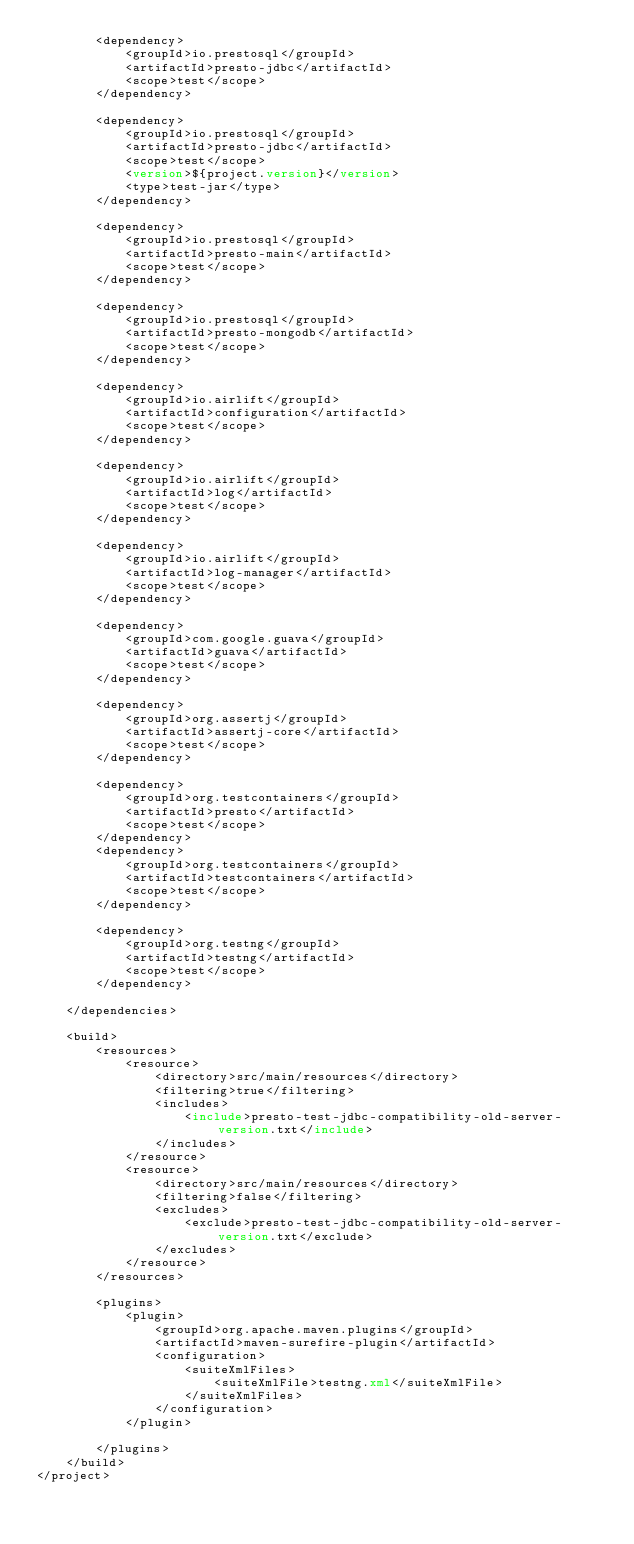<code> <loc_0><loc_0><loc_500><loc_500><_XML_>        <dependency>
            <groupId>io.prestosql</groupId>
            <artifactId>presto-jdbc</artifactId>
            <scope>test</scope>
        </dependency>

        <dependency>
            <groupId>io.prestosql</groupId>
            <artifactId>presto-jdbc</artifactId>
            <scope>test</scope>
            <version>${project.version}</version>
            <type>test-jar</type>
        </dependency>

        <dependency>
            <groupId>io.prestosql</groupId>
            <artifactId>presto-main</artifactId>
            <scope>test</scope>
        </dependency>

        <dependency>
            <groupId>io.prestosql</groupId>
            <artifactId>presto-mongodb</artifactId>
            <scope>test</scope>
        </dependency>

        <dependency>
            <groupId>io.airlift</groupId>
            <artifactId>configuration</artifactId>
            <scope>test</scope>
        </dependency>

        <dependency>
            <groupId>io.airlift</groupId>
            <artifactId>log</artifactId>
            <scope>test</scope>
        </dependency>

        <dependency>
            <groupId>io.airlift</groupId>
            <artifactId>log-manager</artifactId>
            <scope>test</scope>
        </dependency>

        <dependency>
            <groupId>com.google.guava</groupId>
            <artifactId>guava</artifactId>
            <scope>test</scope>
        </dependency>

        <dependency>
            <groupId>org.assertj</groupId>
            <artifactId>assertj-core</artifactId>
            <scope>test</scope>
        </dependency>

        <dependency>
            <groupId>org.testcontainers</groupId>
            <artifactId>presto</artifactId>
            <scope>test</scope>
        </dependency>
        <dependency>
            <groupId>org.testcontainers</groupId>
            <artifactId>testcontainers</artifactId>
            <scope>test</scope>
        </dependency>

        <dependency>
            <groupId>org.testng</groupId>
            <artifactId>testng</artifactId>
            <scope>test</scope>
        </dependency>

    </dependencies>

    <build>
        <resources>
            <resource>
                <directory>src/main/resources</directory>
                <filtering>true</filtering>
                <includes>
                    <include>presto-test-jdbc-compatibility-old-server-version.txt</include>
                </includes>
            </resource>
            <resource>
                <directory>src/main/resources</directory>
                <filtering>false</filtering>
                <excludes>
                    <exclude>presto-test-jdbc-compatibility-old-server-version.txt</exclude>
                </excludes>
            </resource>
        </resources>

        <plugins>
            <plugin>
                <groupId>org.apache.maven.plugins</groupId>
                <artifactId>maven-surefire-plugin</artifactId>
                <configuration>
                    <suiteXmlFiles>
                        <suiteXmlFile>testng.xml</suiteXmlFile>
                    </suiteXmlFiles>
                </configuration>
            </plugin>

        </plugins>
    </build>
</project>
</code> 